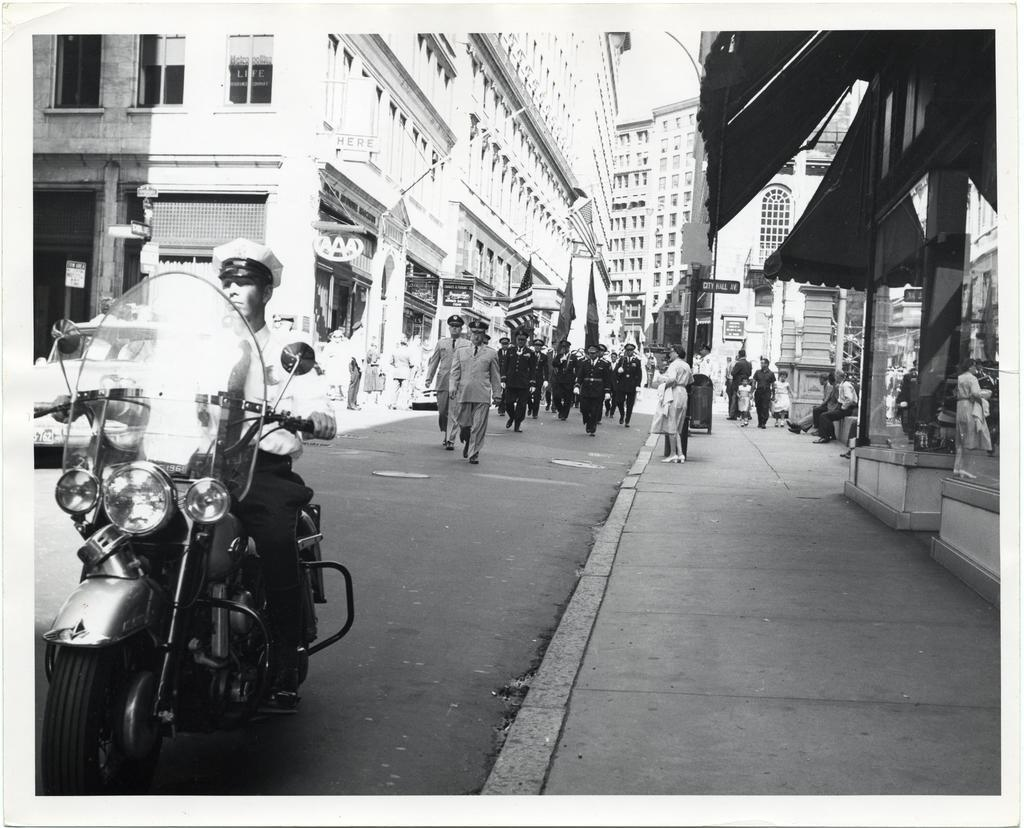What type of structures can be seen in the image? There are buildings in the image. What mode of transportation is present in the image? There is a motorcycle in the image. What are the people in the image doing? There are people walking on the road in the image. How many spiders are crawling on the motorcycle in the image? There are no spiders present in the image; it features a motorcycle and people walking on the road. What type of hole can be seen in the buildings in the image? There are no holes visible in the buildings in the image; only the buildings themselves are present. 